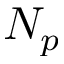Convert formula to latex. <formula><loc_0><loc_0><loc_500><loc_500>N _ { p }</formula> 